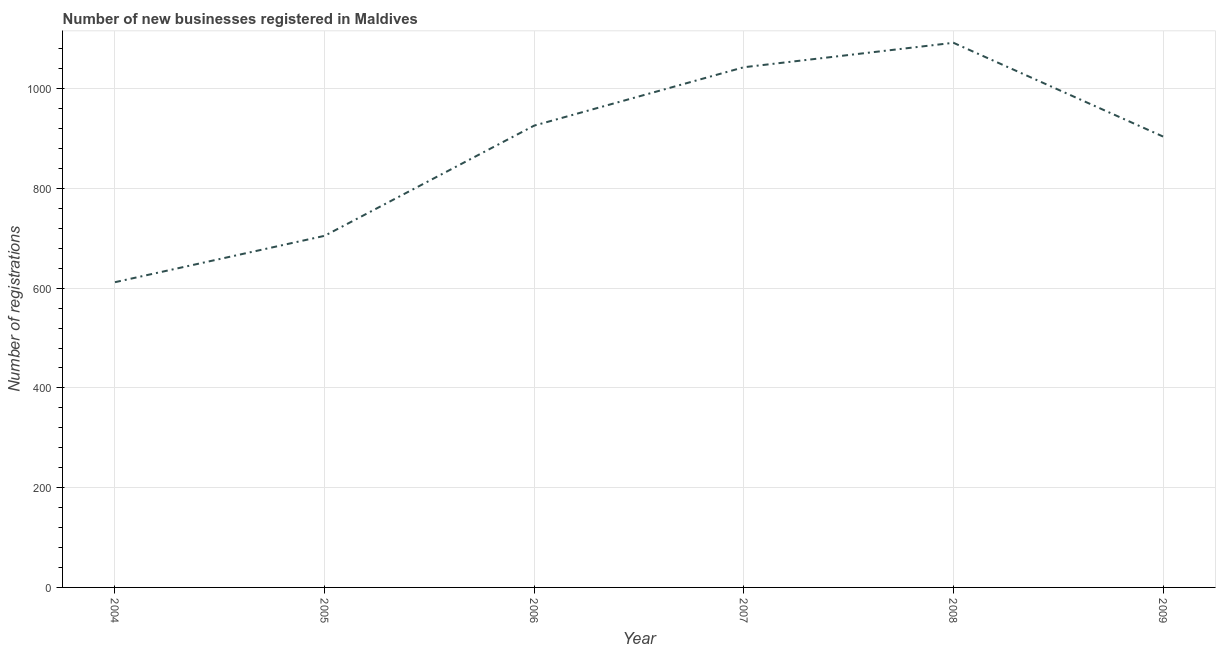What is the number of new business registrations in 2006?
Offer a terse response. 926. Across all years, what is the maximum number of new business registrations?
Make the answer very short. 1092. Across all years, what is the minimum number of new business registrations?
Give a very brief answer. 612. In which year was the number of new business registrations minimum?
Ensure brevity in your answer.  2004. What is the sum of the number of new business registrations?
Your answer should be very brief. 5282. What is the difference between the number of new business registrations in 2004 and 2009?
Offer a very short reply. -292. What is the average number of new business registrations per year?
Your answer should be compact. 880.33. What is the median number of new business registrations?
Provide a succinct answer. 915. In how many years, is the number of new business registrations greater than 720 ?
Offer a very short reply. 4. What is the ratio of the number of new business registrations in 2004 to that in 2007?
Your answer should be compact. 0.59. What is the difference between the highest and the second highest number of new business registrations?
Make the answer very short. 49. Is the sum of the number of new business registrations in 2008 and 2009 greater than the maximum number of new business registrations across all years?
Offer a very short reply. Yes. What is the difference between the highest and the lowest number of new business registrations?
Keep it short and to the point. 480. In how many years, is the number of new business registrations greater than the average number of new business registrations taken over all years?
Your response must be concise. 4. What is the title of the graph?
Give a very brief answer. Number of new businesses registered in Maldives. What is the label or title of the Y-axis?
Your answer should be compact. Number of registrations. What is the Number of registrations of 2004?
Provide a succinct answer. 612. What is the Number of registrations of 2005?
Your response must be concise. 705. What is the Number of registrations of 2006?
Offer a terse response. 926. What is the Number of registrations in 2007?
Give a very brief answer. 1043. What is the Number of registrations of 2008?
Offer a terse response. 1092. What is the Number of registrations of 2009?
Provide a succinct answer. 904. What is the difference between the Number of registrations in 2004 and 2005?
Provide a short and direct response. -93. What is the difference between the Number of registrations in 2004 and 2006?
Your answer should be compact. -314. What is the difference between the Number of registrations in 2004 and 2007?
Offer a very short reply. -431. What is the difference between the Number of registrations in 2004 and 2008?
Offer a terse response. -480. What is the difference between the Number of registrations in 2004 and 2009?
Your response must be concise. -292. What is the difference between the Number of registrations in 2005 and 2006?
Your answer should be very brief. -221. What is the difference between the Number of registrations in 2005 and 2007?
Offer a very short reply. -338. What is the difference between the Number of registrations in 2005 and 2008?
Give a very brief answer. -387. What is the difference between the Number of registrations in 2005 and 2009?
Your response must be concise. -199. What is the difference between the Number of registrations in 2006 and 2007?
Offer a very short reply. -117. What is the difference between the Number of registrations in 2006 and 2008?
Provide a succinct answer. -166. What is the difference between the Number of registrations in 2007 and 2008?
Provide a short and direct response. -49. What is the difference between the Number of registrations in 2007 and 2009?
Your answer should be very brief. 139. What is the difference between the Number of registrations in 2008 and 2009?
Offer a terse response. 188. What is the ratio of the Number of registrations in 2004 to that in 2005?
Your answer should be very brief. 0.87. What is the ratio of the Number of registrations in 2004 to that in 2006?
Your response must be concise. 0.66. What is the ratio of the Number of registrations in 2004 to that in 2007?
Ensure brevity in your answer.  0.59. What is the ratio of the Number of registrations in 2004 to that in 2008?
Give a very brief answer. 0.56. What is the ratio of the Number of registrations in 2004 to that in 2009?
Offer a terse response. 0.68. What is the ratio of the Number of registrations in 2005 to that in 2006?
Your response must be concise. 0.76. What is the ratio of the Number of registrations in 2005 to that in 2007?
Provide a short and direct response. 0.68. What is the ratio of the Number of registrations in 2005 to that in 2008?
Make the answer very short. 0.65. What is the ratio of the Number of registrations in 2005 to that in 2009?
Make the answer very short. 0.78. What is the ratio of the Number of registrations in 2006 to that in 2007?
Keep it short and to the point. 0.89. What is the ratio of the Number of registrations in 2006 to that in 2008?
Offer a terse response. 0.85. What is the ratio of the Number of registrations in 2007 to that in 2008?
Make the answer very short. 0.95. What is the ratio of the Number of registrations in 2007 to that in 2009?
Keep it short and to the point. 1.15. What is the ratio of the Number of registrations in 2008 to that in 2009?
Your response must be concise. 1.21. 